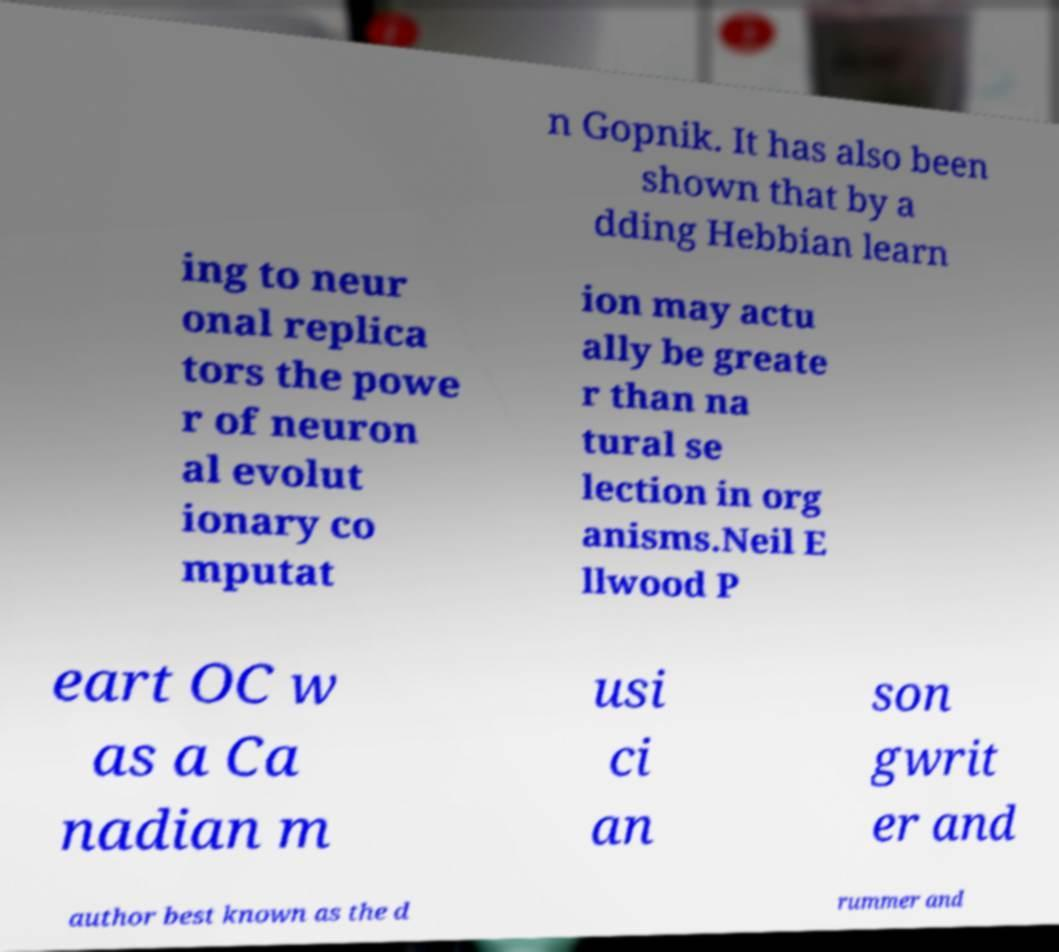What messages or text are displayed in this image? I need them in a readable, typed format. n Gopnik. It has also been shown that by a dding Hebbian learn ing to neur onal replica tors the powe r of neuron al evolut ionary co mputat ion may actu ally be greate r than na tural se lection in org anisms.Neil E llwood P eart OC w as a Ca nadian m usi ci an son gwrit er and author best known as the d rummer and 